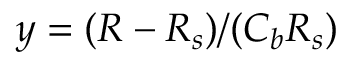<formula> <loc_0><loc_0><loc_500><loc_500>y = ( R - R _ { s } ) / ( C _ { b } R _ { s } )</formula> 